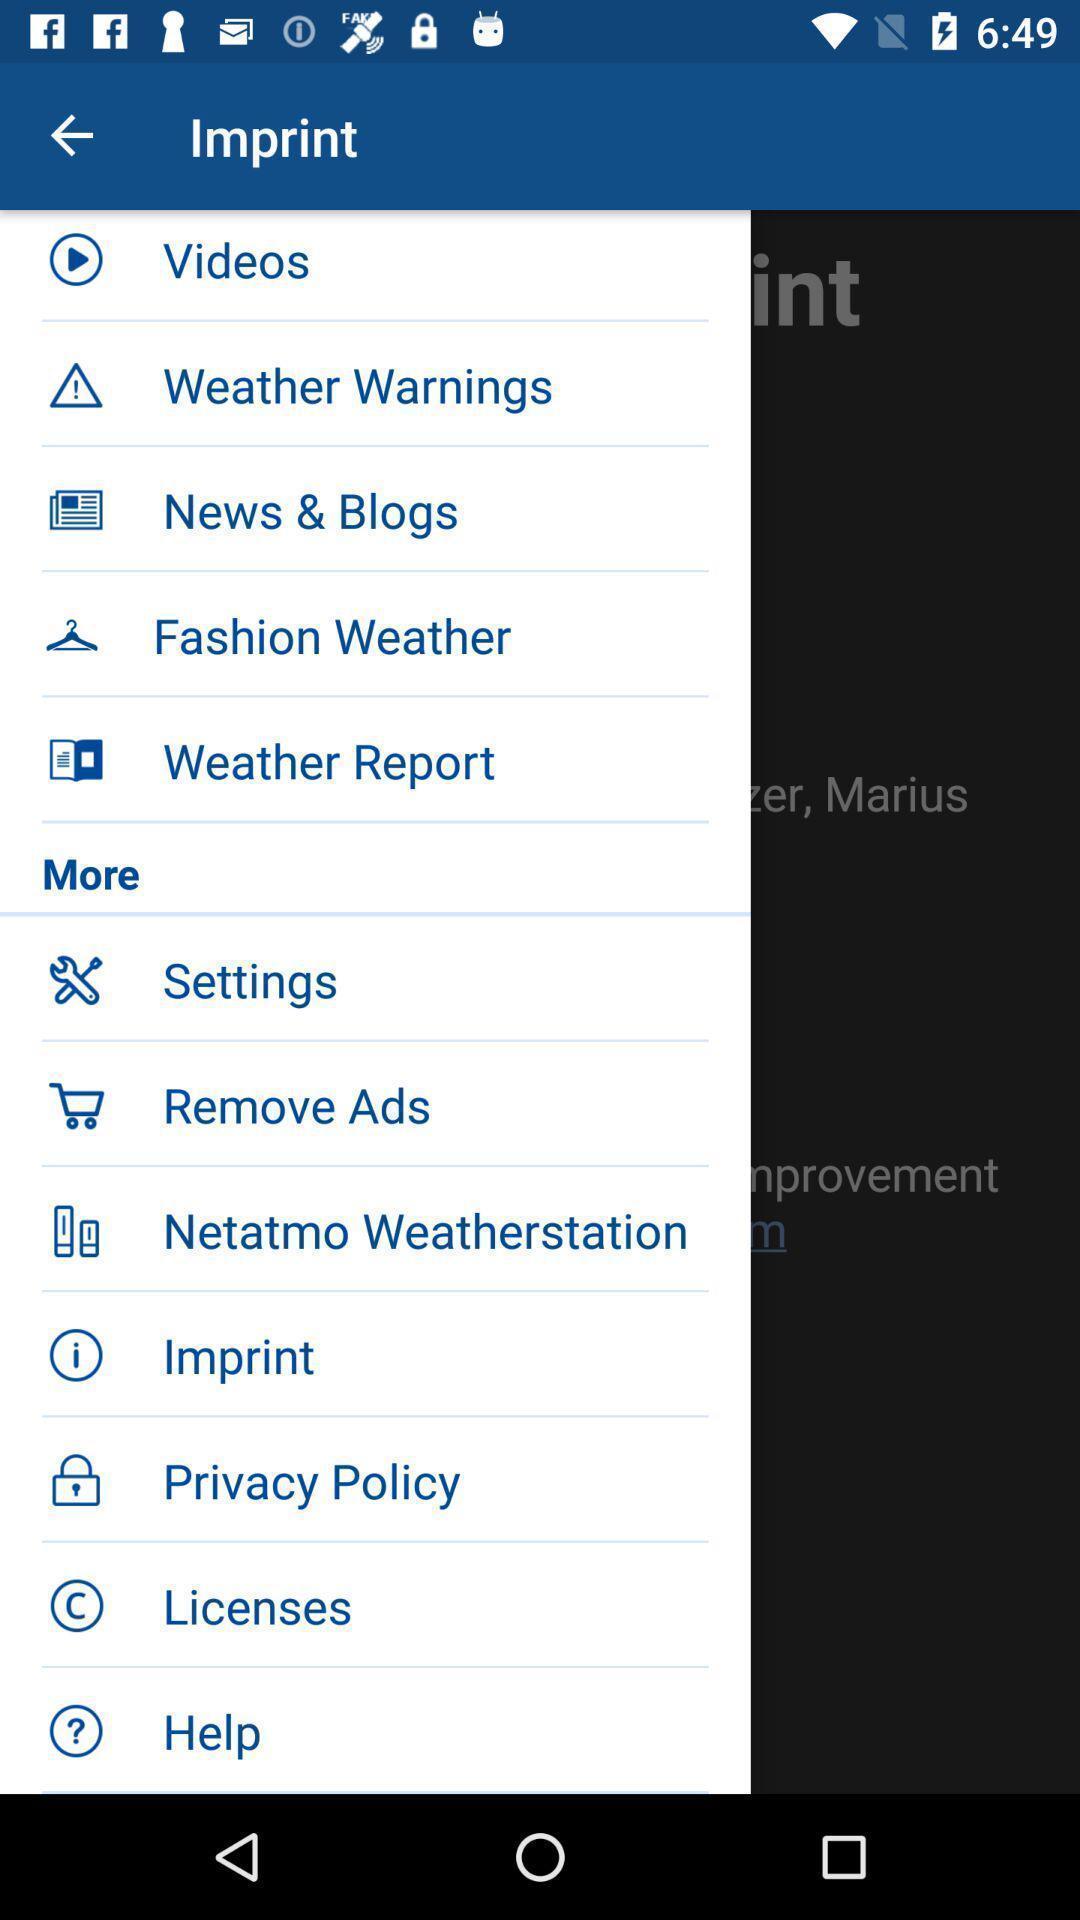Describe this image in words. Page displaying list of options. 